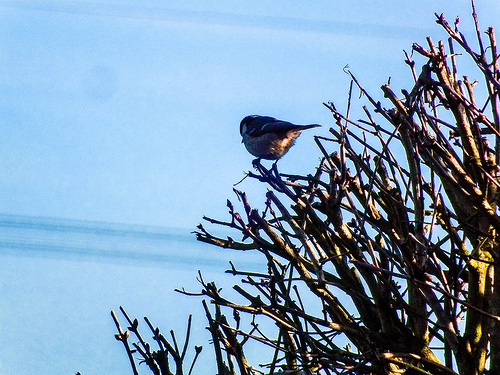<image>
Is the bird on the sky? No. The bird is not positioned on the sky. They may be near each other, but the bird is not supported by or resting on top of the sky. Is there a bird in the sky? No. The bird is not contained within the sky. These objects have a different spatial relationship. 